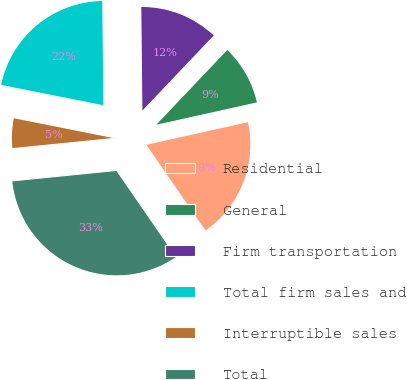Convert chart. <chart><loc_0><loc_0><loc_500><loc_500><pie_chart><fcel>Residential<fcel>General<fcel>Firm transportation<fcel>Total firm sales and<fcel>Interruptible sales<fcel>Total<nl><fcel>18.87%<fcel>9.43%<fcel>12.26%<fcel>21.7%<fcel>4.72%<fcel>33.02%<nl></chart> 